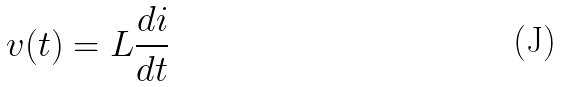Convert formula to latex. <formula><loc_0><loc_0><loc_500><loc_500>v ( t ) = L \frac { d i } { d t }</formula> 